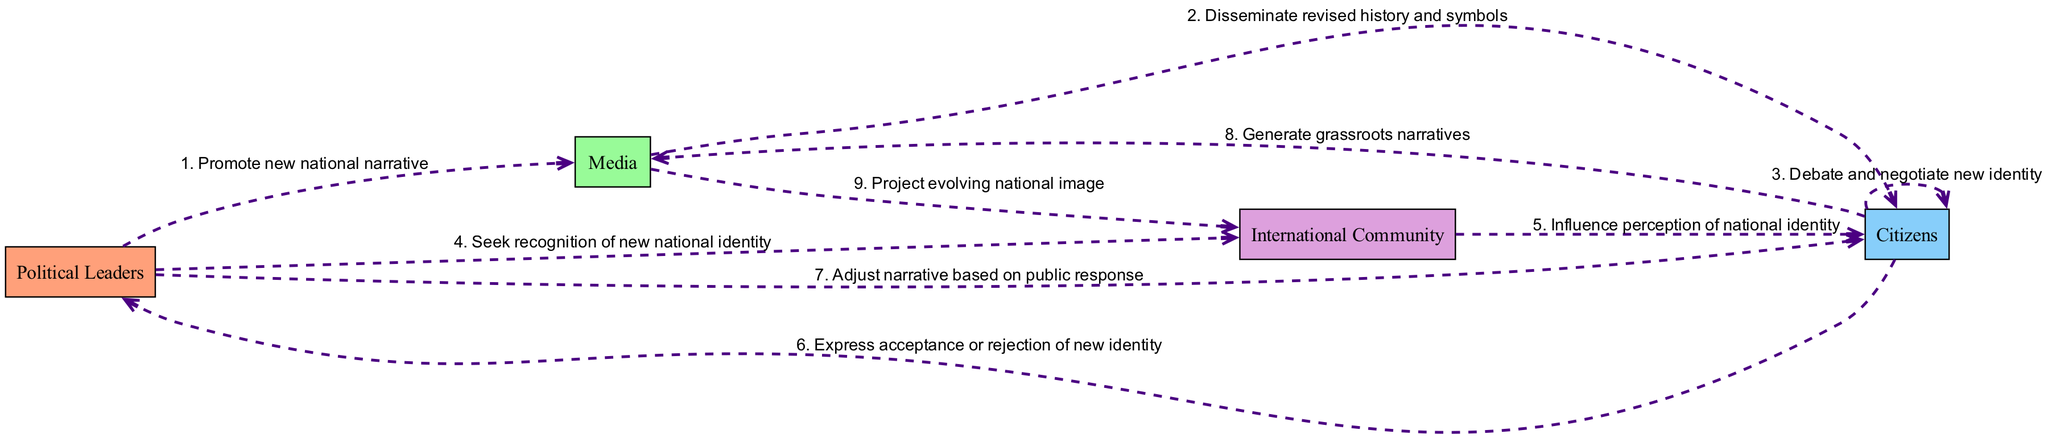What are the actors involved in the sequence diagram? The diagram defines four distinct actors: Political Leaders, Media, Citizens, and the International Community. These actors interact with each other through the events depicted in the diagram.
Answer: Political Leaders, Media, Citizens, International Community How many events are depicted in the diagram? The diagram contains a total of nine events that illustrate the interactions between the various actors and their roles in shaping national identity during political upheaval.
Answer: 9 Which actor is involved in seeking recognition of the new national identity? The event showing the action "Seek recognition of new national identity" is connected from the Political Leaders to the International Community, indicating that the Political Leaders play this role.
Answer: Political Leaders What is the action taken by Media towards Citizens? The Media disseminates revised history and symbols to Citizens, which shows the role of Media in shaping how Citizens perceive their national identity during the upheaval.
Answer: Disseminate revised history and symbols Which actor expresses acceptance or rejection of the new identity? The event "Express acceptance or rejection of new identity" is initiated by Citizens, showing they are the ones who respond to the new narrative proposed by the Political Leaders.
Answer: Citizens What influences the perception of national identity among Citizens? The International Community influences the perception of national identity by interacting with the Citizens, indicating the importance of external perspectives in the identity formation process.
Answer: Influence perception of national identity How does Political Leaders respond to the public's reaction regarding the new identity? The event "Adjust narrative based on public response" indicates that Political Leaders modify their narrative based on how Citizens accept or reject the proposed identity, showing a feedback loop in the process.
Answer: Adjust narrative based on public response Which event leads to the creation of grassroots narratives? The event where Citizens generate grassroots narratives occurs after they interact with each other to debate and negotiate their new identity, reflecting a bottom-up approach to identity formation.
Answer: Generate grassroots narratives What sequence connects the Media to the International Community? The action "Project evolving national image" shows the relationship where Media communicates the changes in national identity to the International Community, linking the internal and external dimensions of the identity discourse.
Answer: Project evolving national image 